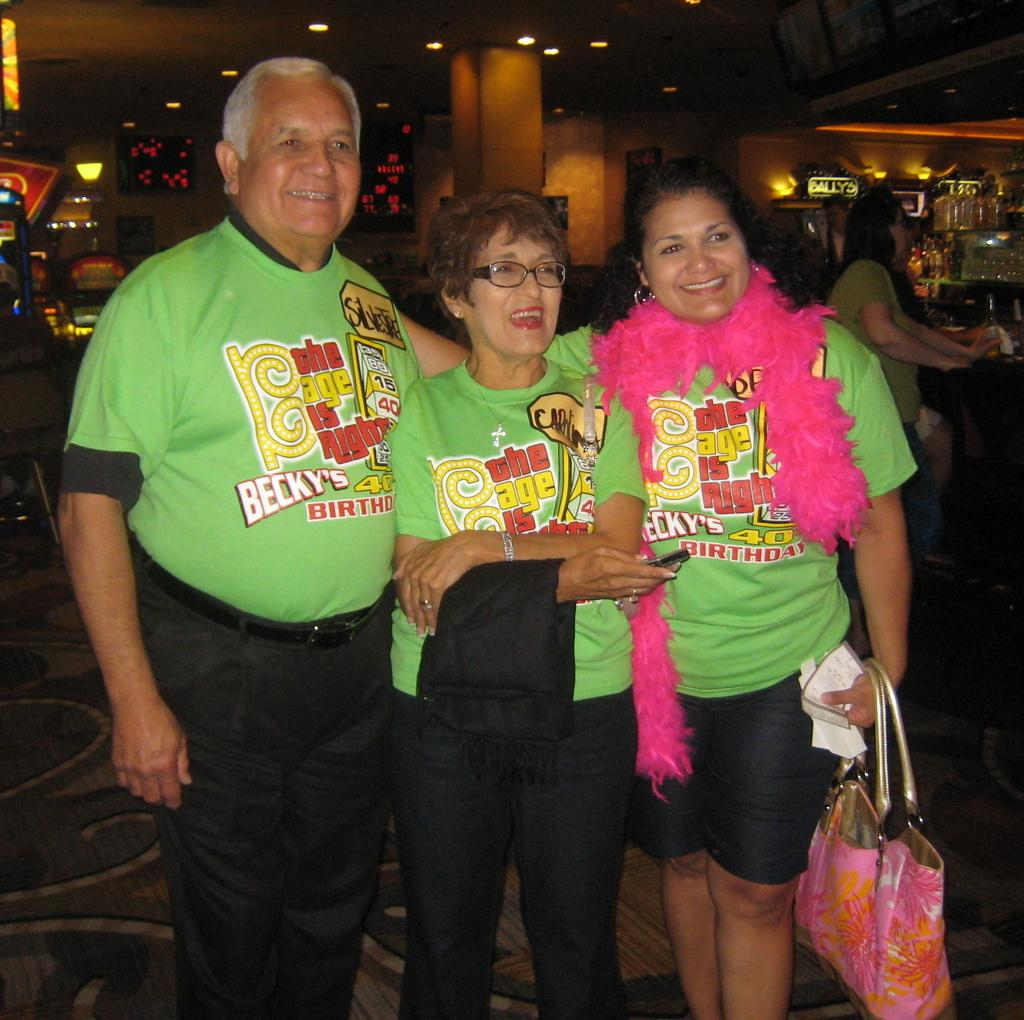Who is the person on the left side of the image? There is an old man standing on the left side of the image. Who is the person in the middle of the image? There is an old woman in the middle of the image. Who is the person on the right side of the image? There is a lady standing on the right side of the image. What is the lady holding in the image? The lady is holding a bag. What type of creature is sitting on the roof in the image? There is no creature sitting on the roof in the image, as there is no roof or creature mentioned in the provided facts. 